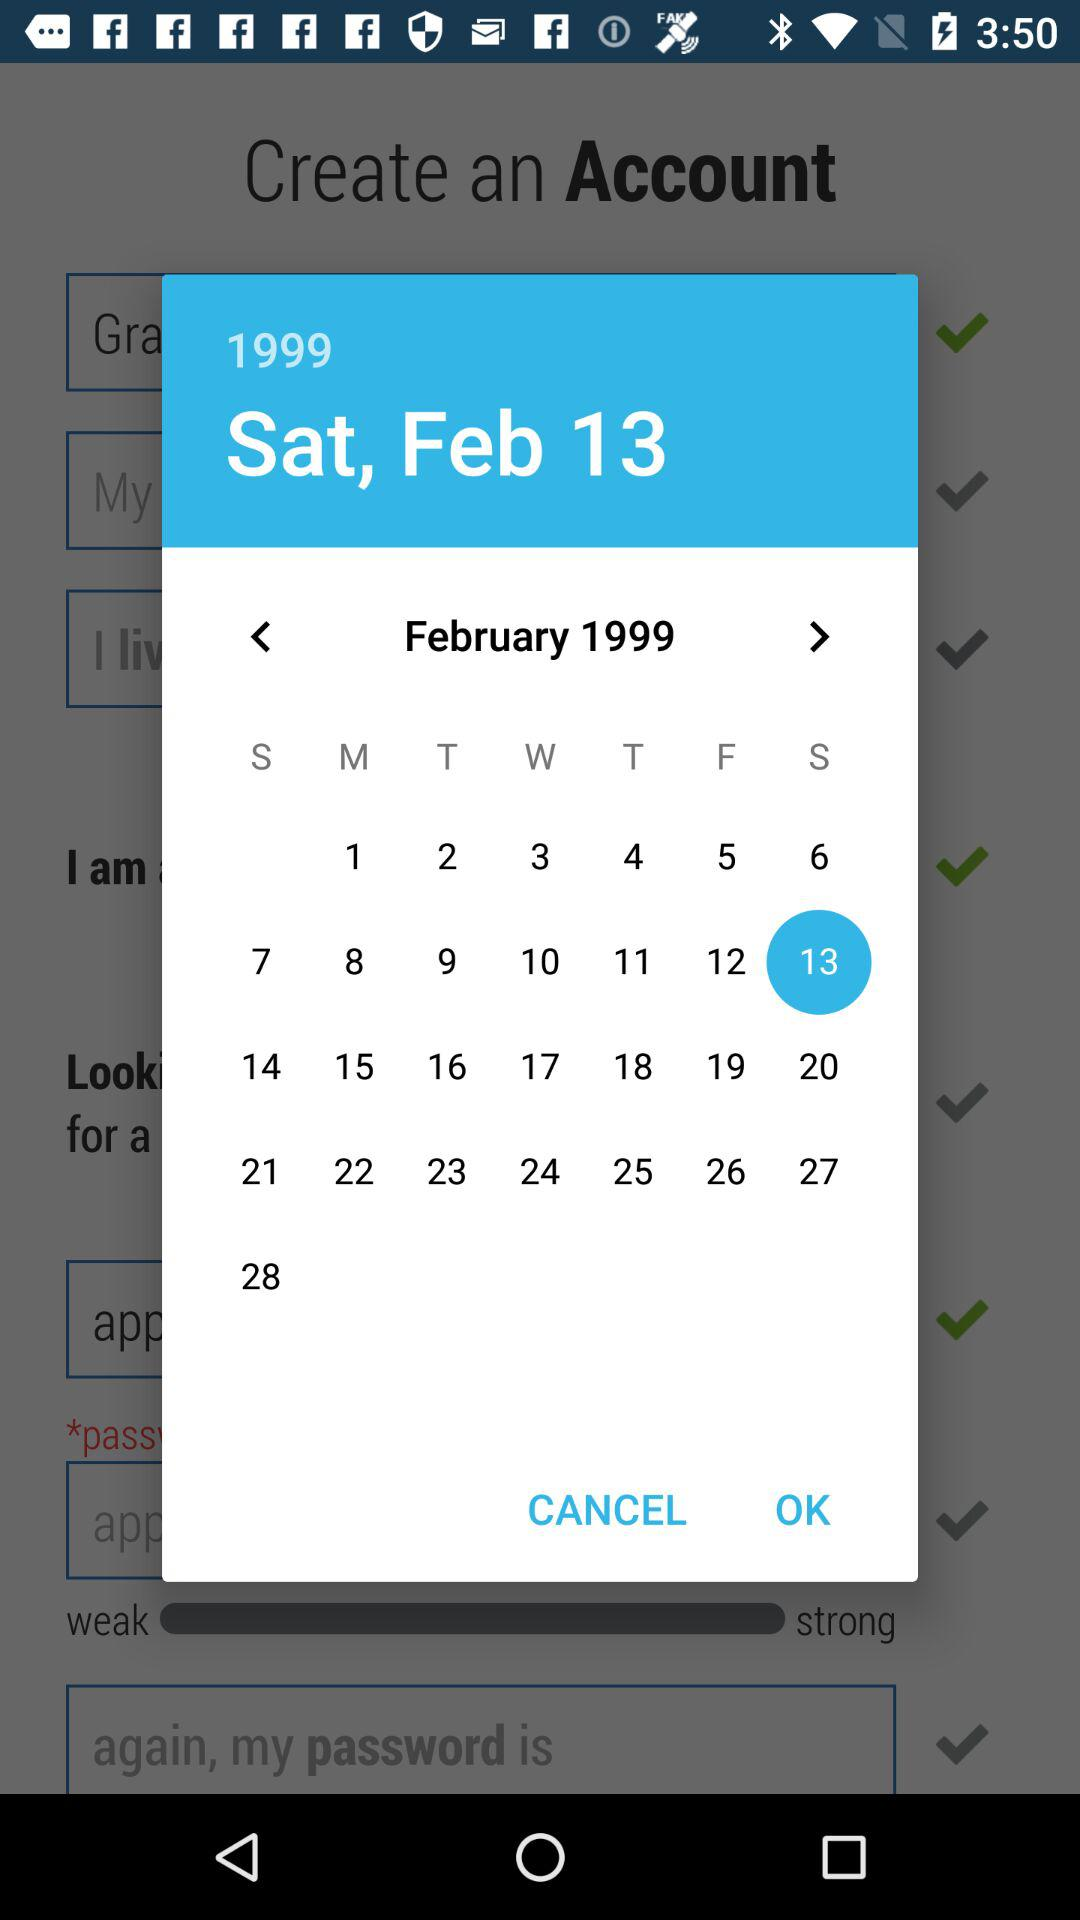What day is it on February 10, 1999, on the calendar? The day is Saturday. 